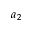Convert formula to latex. <formula><loc_0><loc_0><loc_500><loc_500>a _ { 2 }</formula> 